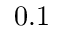Convert formula to latex. <formula><loc_0><loc_0><loc_500><loc_500>0 . 1</formula> 